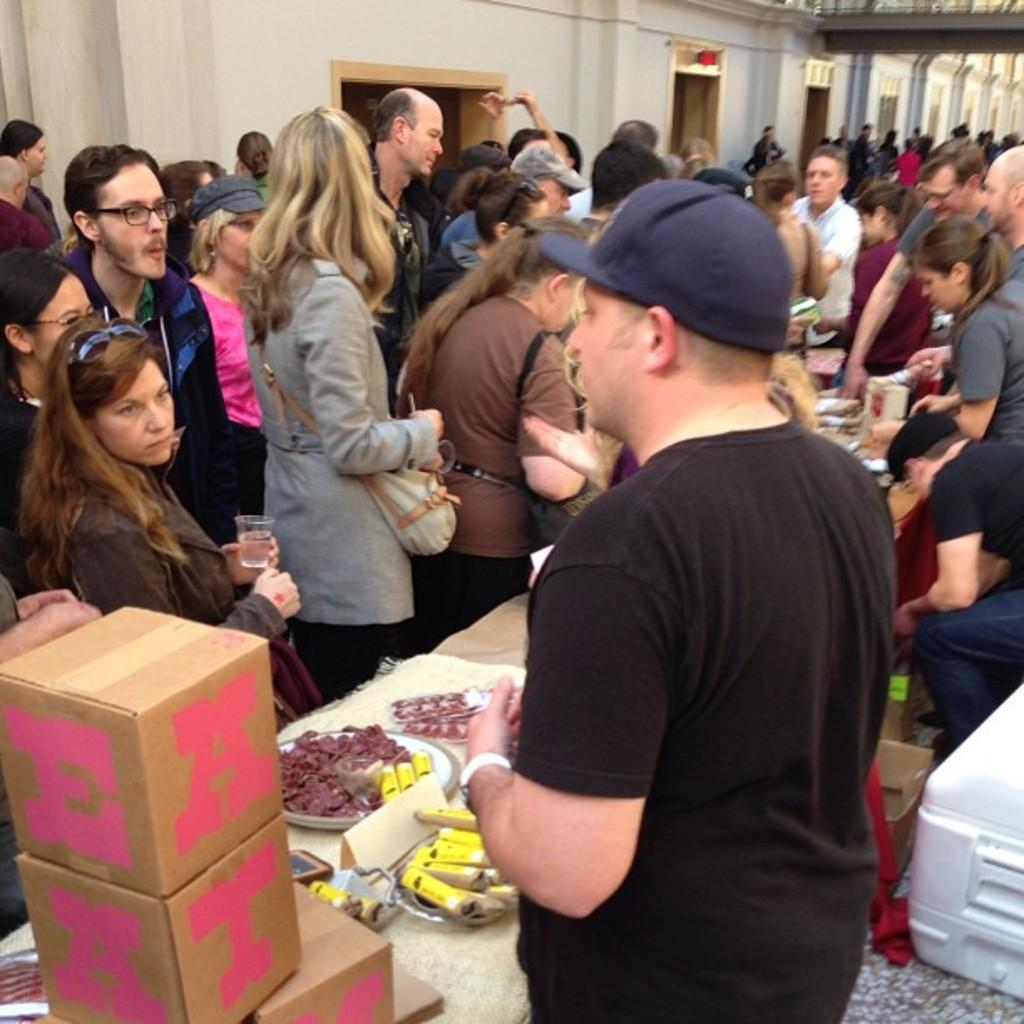Who or what can be seen in the image? There are people in the image. What is present in the image besides the people? There is a table in the image. What is on the table? There are boxes on the table, as well as other unspecified items. Is there a tray visible in the image? There is no mention of a tray in the provided facts, so it cannot be confirmed whether a tray is present in the image. 